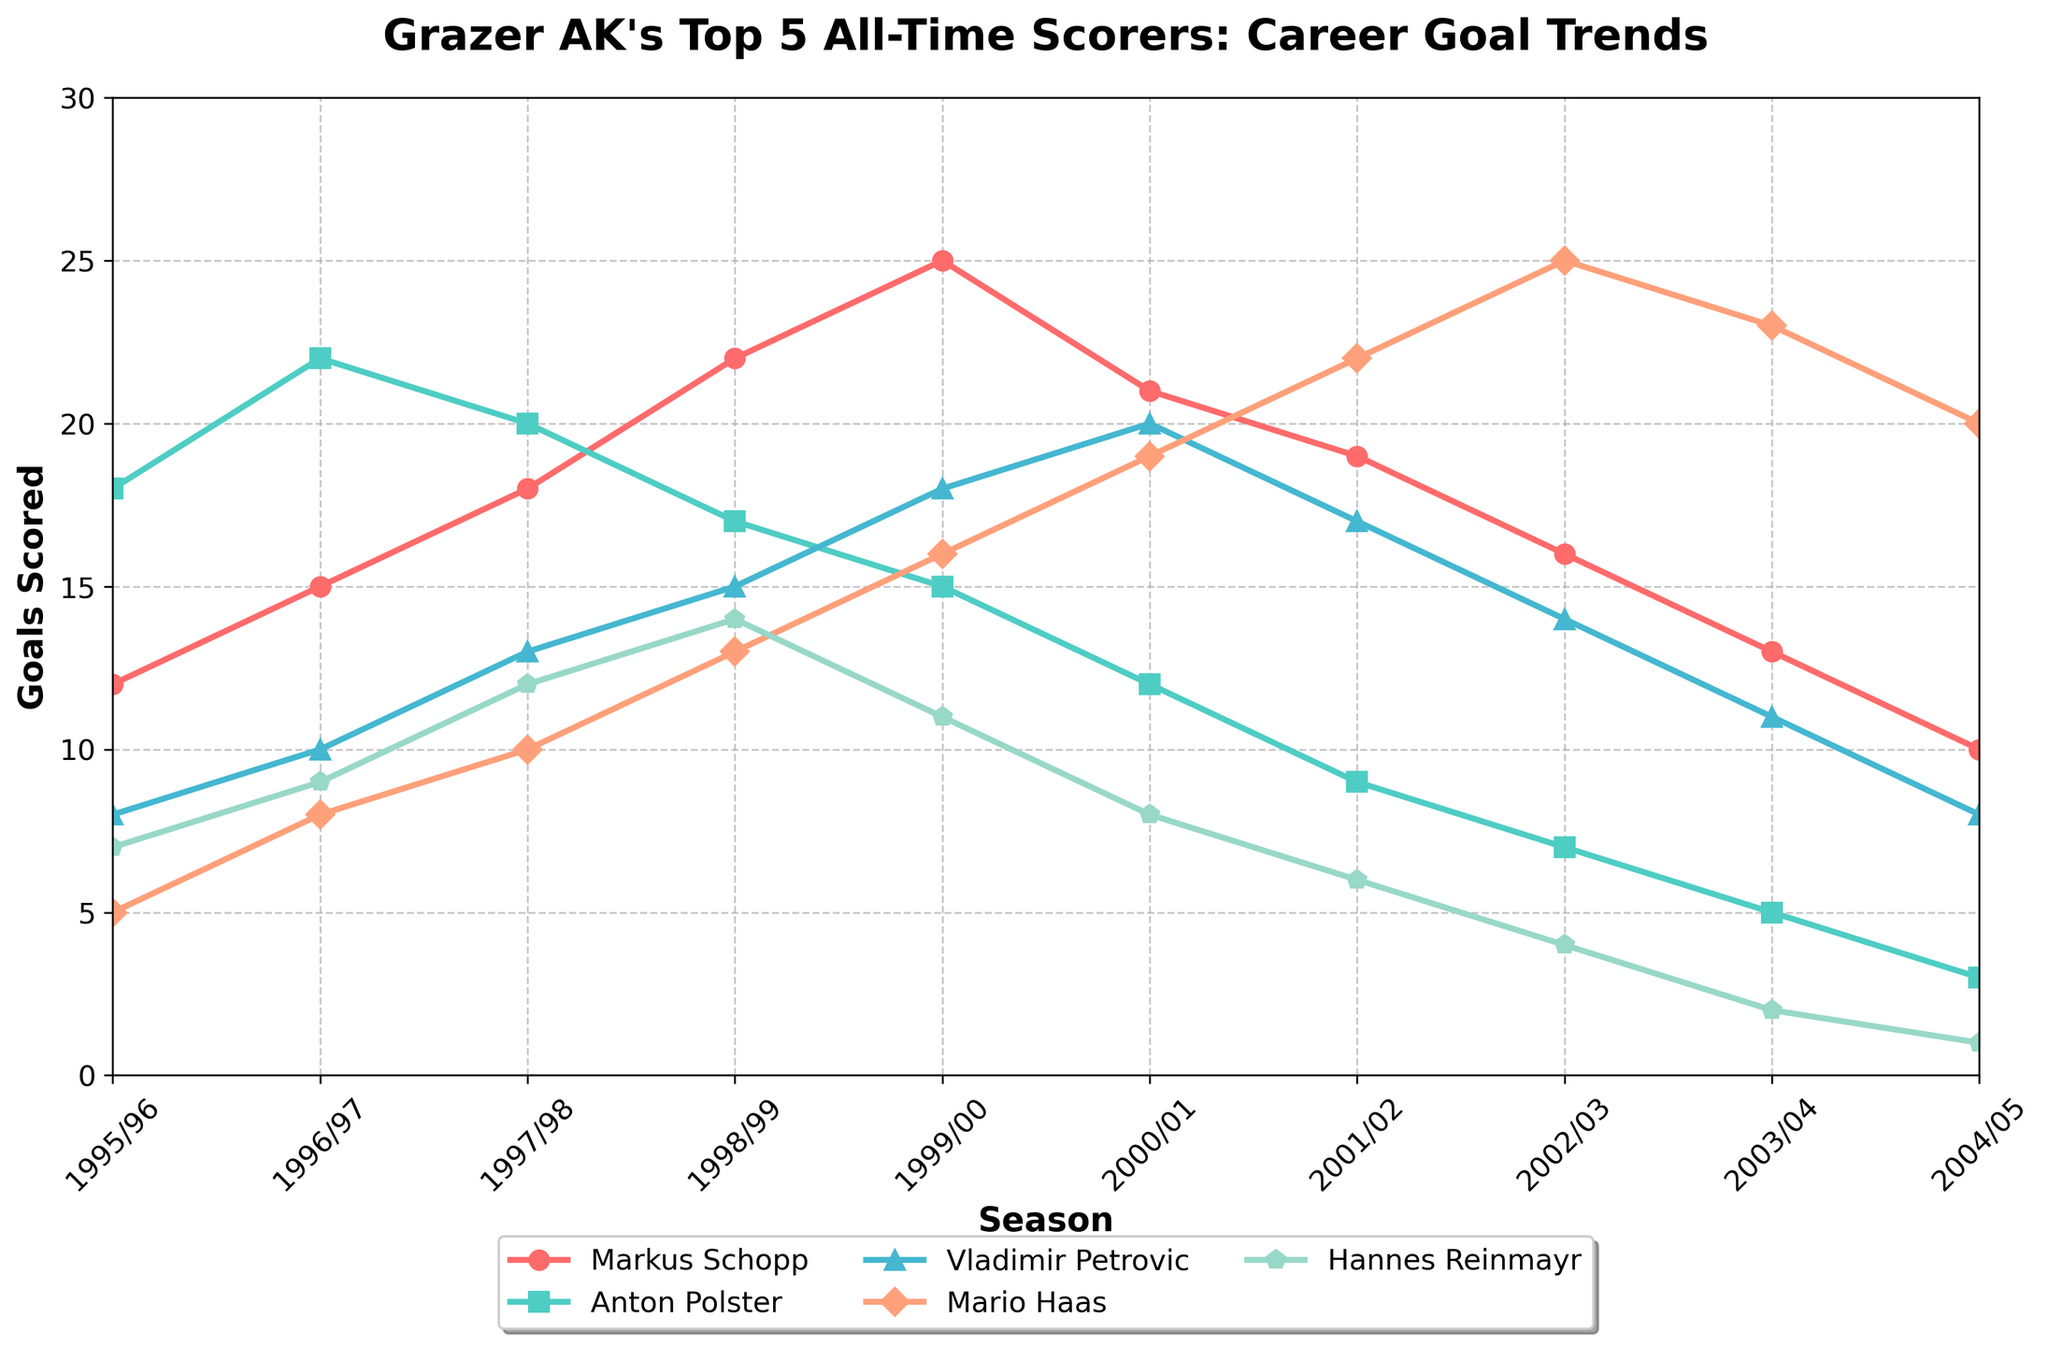What's the maximum number of goals scored by any player in a single season? To find this, look at the highest point on any of the lines in the graph. The highest point corresponds to 25 goals, scored by Mario Haas in the 2002/03 season.
Answer: 25 Which player's goal-scoring trend shows the most consistent decline over the seasons? Examine each player's line trend from start to finish. Markus Schopp's line shows a consistent decline from the 1999/00 season onward compared to others.
Answer: Markus Schopp In which season did Anton Polster and Vladimir Petrovic have the same number of goals? Identify the points where Anton Polster's and Vladimir Petrovic's lines intersect. Both players scored 17 goals in the 1998/99 season.
Answer: 1998/99 What's the total number of goals scored by Mario Haas across all the seasons? Sum up the goals scored by Mario Haas from each season: 5 + 8 + 10 + 13 + 16 + 19 + 22 + 25 + 23 + 20 = 161
Answer: 161 Which player had the highest goal count in the 1999/00 season, and how many goals did he score? Look at the values for each player in the 1999/00 season and find the highest one. Vladimir Petrovic scored the highest with 18 goals.
Answer: Vladimir Petrovic, 18 Who scored the fewest goals in the 2004/05 season, and how many? Check each player's goal count for the 2004/05 season and identify the lowest one. Hannes Reinmayr scored the fewest with 1 goal.
Answer: Hannes Reinmayr, 1 Which player showed the greatest improvement in goals scored from the 1995/96 season to the 1996/97 season? Calculate the difference in goals scored between the two seasons for each player. Markus Schopp improved by 3 goals (15-12), Anton Polster by 4 goals (22-18), Vladimir Petrovic by 2 goals (10-8), Mario Haas by 3 goals (8-5), and Hannes Reinmayr by 2 goals (9-7). Anton Polster shows the greatest improvement.
Answer: Anton Polster What is the average number of goals per season for Hannes Reinmayr? Add up the goals scored by Hannes Reinmayr and divide by the number of seasons: (7 + 9 + 12 + 14 + 11 + 8 + 6 + 4 + 2 + 1)/10 = 7.4
Answer: 7.4 How many goals did Vladimir Petrovic score over the last three seasons? Sum the goals Vladimir Petrovic scored in the last three seasons: 14 + 11 + 8 = 33
Answer: 33 Compare the goal trends of Mario Haas and Vladimir Petrovic: who showed a more consistent upward trend from 1995/96 to 2002/03? Analyze both trends; Mario Haas shows a consistent upward trend reaching a peak in 2002/03, while Vladimir Petrovic has oscillations. Thus, Mario Haas shows a more consistent trend.
Answer: Mario Haas 